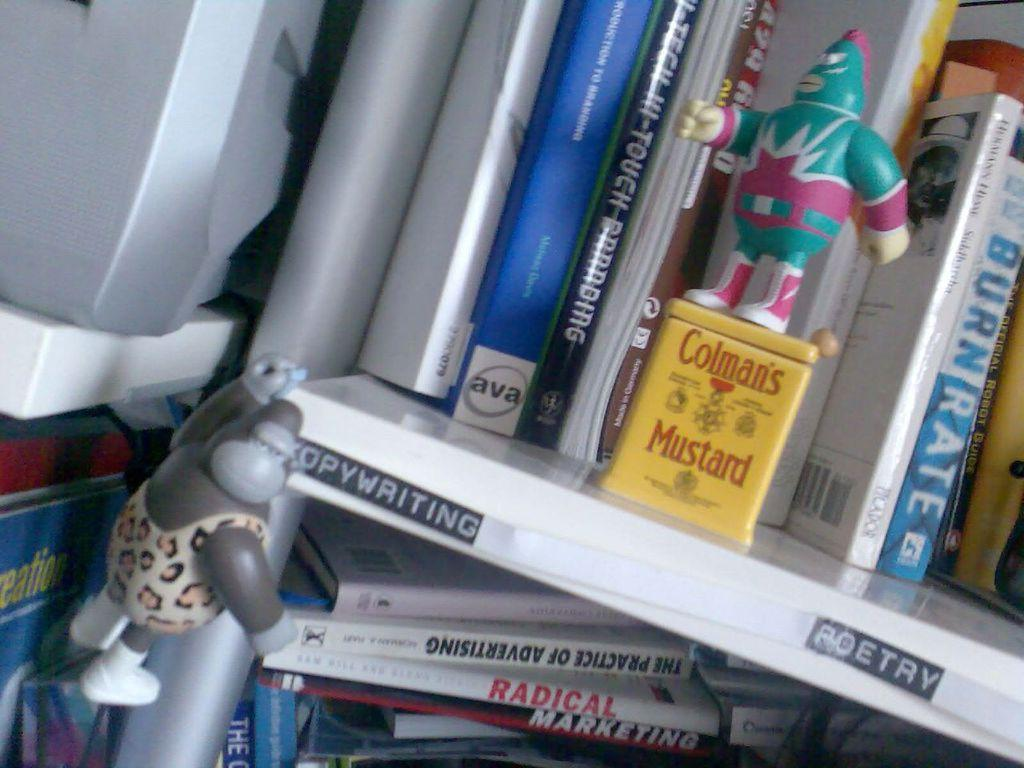<image>
Relay a brief, clear account of the picture shown. A shelf of books with labels for copywriting and poetry and a green action figure standing on a yellow Colamn's Mustard can 